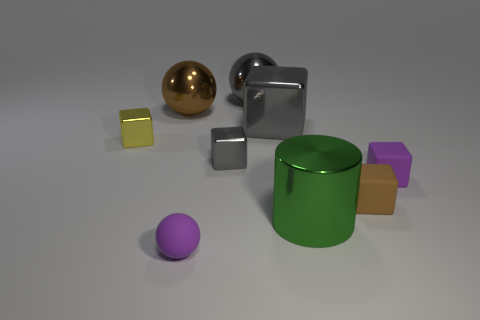Subtract 1 blocks. How many blocks are left? 4 Subtract all small gray cubes. How many cubes are left? 4 Subtract all purple cubes. How many cubes are left? 4 Subtract all red cubes. Subtract all brown spheres. How many cubes are left? 5 Subtract all cubes. How many objects are left? 4 Add 1 small gray things. How many objects exist? 10 Subtract all green metal cylinders. Subtract all tiny matte spheres. How many objects are left? 7 Add 2 yellow metallic blocks. How many yellow metallic blocks are left? 3 Add 9 purple shiny balls. How many purple shiny balls exist? 9 Subtract 1 gray balls. How many objects are left? 8 